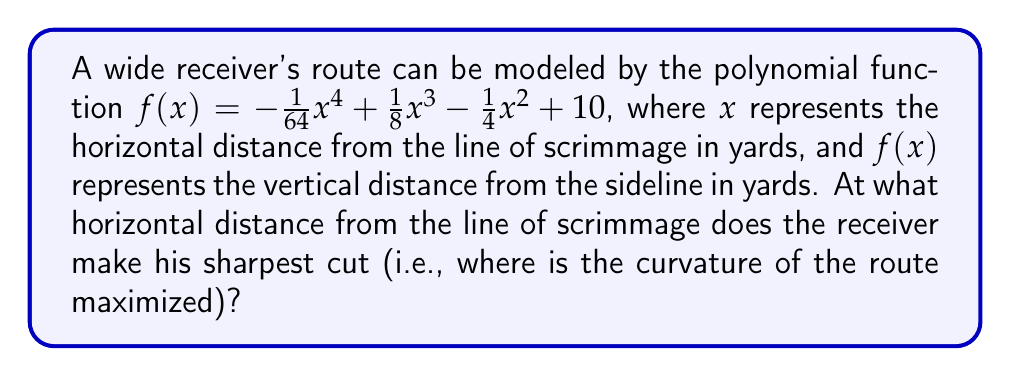Solve this math problem. To find the point of maximum curvature, we need to follow these steps:

1) The curvature of a function $f(x)$ is given by:

   $$\kappa(x) = \frac{|f''(x)|}{(1 + (f'(x))^2)^{3/2}}$$

2) First, let's find $f'(x)$ and $f''(x)$:

   $f'(x) = -\frac{1}{16}x^3 + \frac{3}{8}x^2 - \frac{1}{2}x$
   $f''(x) = -\frac{3}{16}x^2 + \frac{3}{4}x - \frac{1}{2}$

3) Now, we need to find the maximum of $\kappa(x)$. This occurs at the same $x$ value where $|f''(x)|$ is maximized, because the denominator is always positive.

4) To find the maximum of $|f''(x)|$, we can find where $f'''(x) = 0$:

   $f'''(x) = -\frac{3}{8}x + \frac{3}{4} = 0$

5) Solving this equation:

   $-\frac{3}{8}x + \frac{3}{4} = 0$
   $-\frac{3}{8}x = -\frac{3}{4}$
   $x = 2$

6) We can confirm this is a maximum by checking the sign of $f'''(x)$ on either side of $x = 2$.

Therefore, the curvature is maximized at $x = 2$ yards from the line of scrimmage.
Answer: The receiver makes his sharpest cut at 2 yards from the line of scrimmage. 